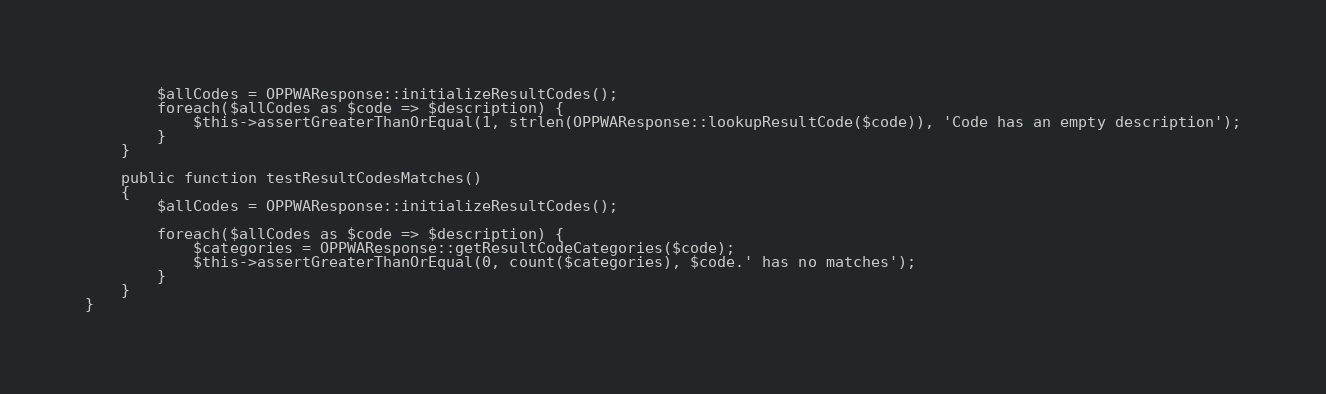Convert code to text. <code><loc_0><loc_0><loc_500><loc_500><_PHP_>		$allCodes = OPPWAResponse::initializeResultCodes();
		foreach($allCodes as $code => $description) {
			$this->assertGreaterThanOrEqual(1, strlen(OPPWAResponse::lookupResultCode($code)), 'Code has an empty description');
		}
	}
	
	public function testResultCodesMatches()
	{
		$allCodes = OPPWAResponse::initializeResultCodes();
		
		foreach($allCodes as $code => $description) {
			$categories = OPPWAResponse::getResultCodeCategories($code);
			$this->assertGreaterThanOrEqual(0, count($categories), $code.' has no matches');
		}
	}
}
</code> 